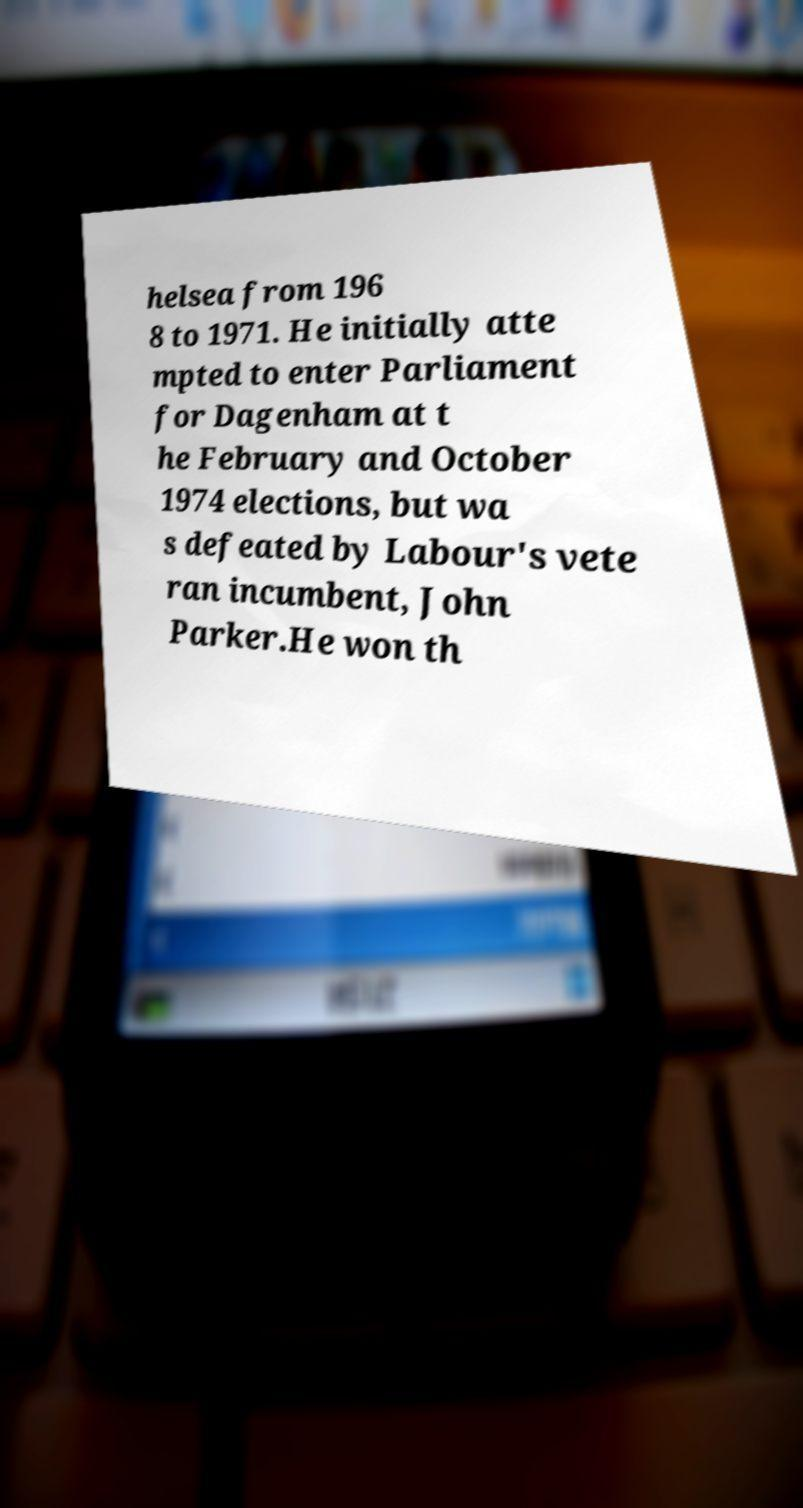For documentation purposes, I need the text within this image transcribed. Could you provide that? helsea from 196 8 to 1971. He initially atte mpted to enter Parliament for Dagenham at t he February and October 1974 elections, but wa s defeated by Labour's vete ran incumbent, John Parker.He won th 